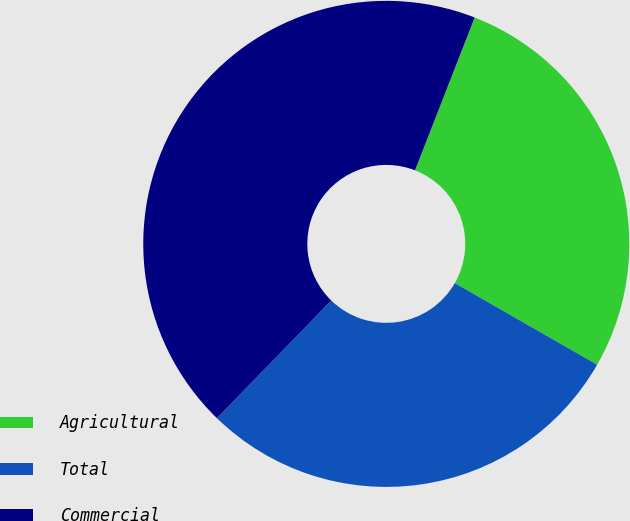<chart> <loc_0><loc_0><loc_500><loc_500><pie_chart><fcel>Agricultural<fcel>Total<fcel>Commercial<nl><fcel>27.36%<fcel>28.99%<fcel>43.66%<nl></chart> 